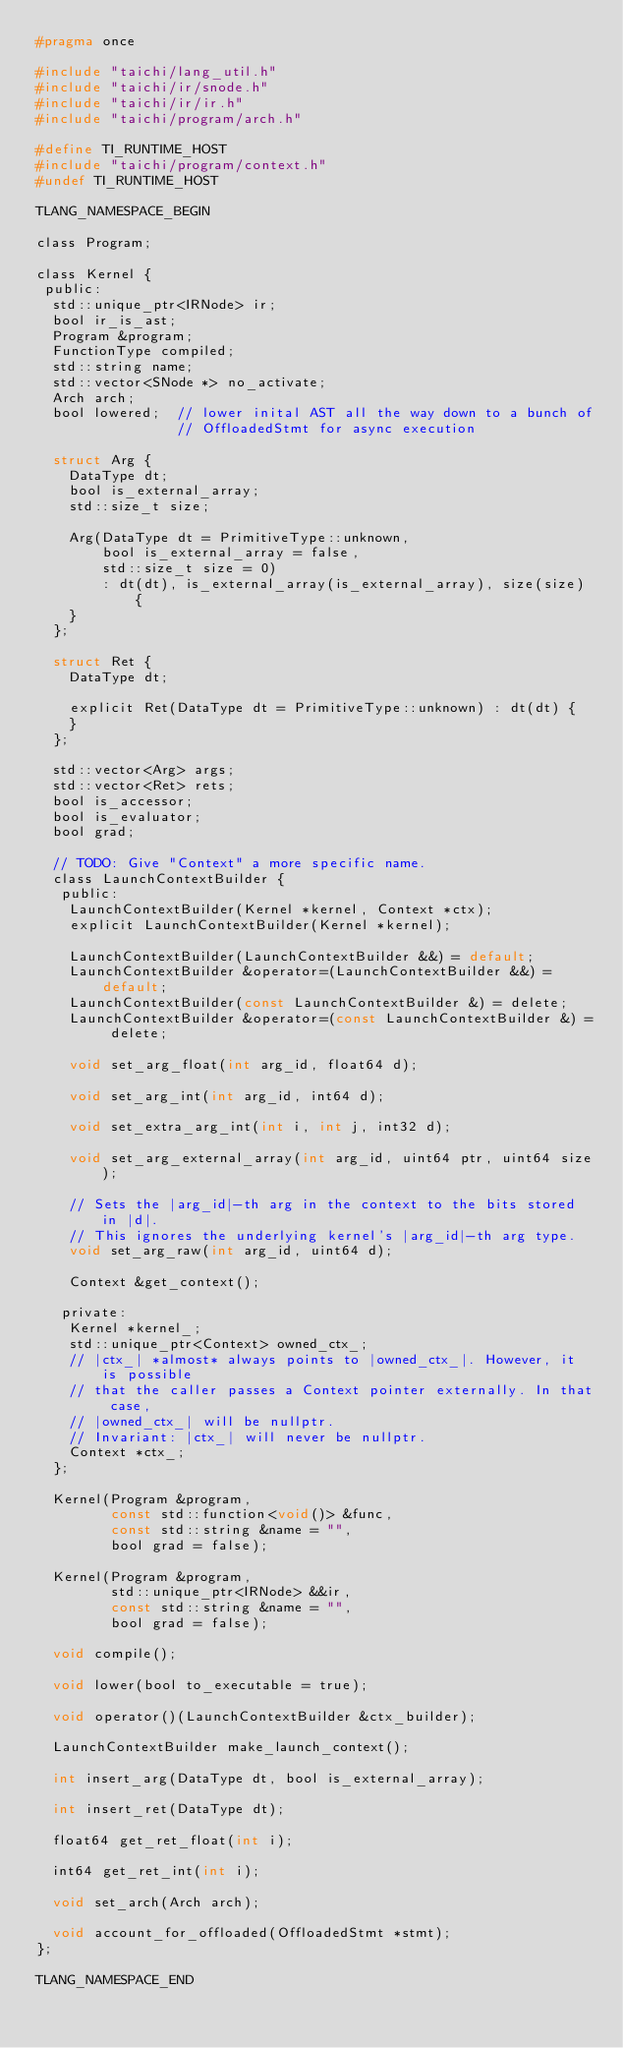<code> <loc_0><loc_0><loc_500><loc_500><_C_>#pragma once

#include "taichi/lang_util.h"
#include "taichi/ir/snode.h"
#include "taichi/ir/ir.h"
#include "taichi/program/arch.h"

#define TI_RUNTIME_HOST
#include "taichi/program/context.h"
#undef TI_RUNTIME_HOST

TLANG_NAMESPACE_BEGIN

class Program;

class Kernel {
 public:
  std::unique_ptr<IRNode> ir;
  bool ir_is_ast;
  Program &program;
  FunctionType compiled;
  std::string name;
  std::vector<SNode *> no_activate;
  Arch arch;
  bool lowered;  // lower inital AST all the way down to a bunch of
                 // OffloadedStmt for async execution

  struct Arg {
    DataType dt;
    bool is_external_array;
    std::size_t size;

    Arg(DataType dt = PrimitiveType::unknown,
        bool is_external_array = false,
        std::size_t size = 0)
        : dt(dt), is_external_array(is_external_array), size(size) {
    }
  };

  struct Ret {
    DataType dt;

    explicit Ret(DataType dt = PrimitiveType::unknown) : dt(dt) {
    }
  };

  std::vector<Arg> args;
  std::vector<Ret> rets;
  bool is_accessor;
  bool is_evaluator;
  bool grad;

  // TODO: Give "Context" a more specific name.
  class LaunchContextBuilder {
   public:
    LaunchContextBuilder(Kernel *kernel, Context *ctx);
    explicit LaunchContextBuilder(Kernel *kernel);

    LaunchContextBuilder(LaunchContextBuilder &&) = default;
    LaunchContextBuilder &operator=(LaunchContextBuilder &&) = default;
    LaunchContextBuilder(const LaunchContextBuilder &) = delete;
    LaunchContextBuilder &operator=(const LaunchContextBuilder &) = delete;

    void set_arg_float(int arg_id, float64 d);

    void set_arg_int(int arg_id, int64 d);

    void set_extra_arg_int(int i, int j, int32 d);

    void set_arg_external_array(int arg_id, uint64 ptr, uint64 size);

    // Sets the |arg_id|-th arg in the context to the bits stored in |d|.
    // This ignores the underlying kernel's |arg_id|-th arg type.
    void set_arg_raw(int arg_id, uint64 d);

    Context &get_context();

   private:
    Kernel *kernel_;
    std::unique_ptr<Context> owned_ctx_;
    // |ctx_| *almost* always points to |owned_ctx_|. However, it is possible
    // that the caller passes a Context pointer externally. In that case,
    // |owned_ctx_| will be nullptr.
    // Invariant: |ctx_| will never be nullptr.
    Context *ctx_;
  };

  Kernel(Program &program,
         const std::function<void()> &func,
         const std::string &name = "",
         bool grad = false);

  Kernel(Program &program,
         std::unique_ptr<IRNode> &&ir,
         const std::string &name = "",
         bool grad = false);

  void compile();

  void lower(bool to_executable = true);

  void operator()(LaunchContextBuilder &ctx_builder);

  LaunchContextBuilder make_launch_context();

  int insert_arg(DataType dt, bool is_external_array);

  int insert_ret(DataType dt);

  float64 get_ret_float(int i);

  int64 get_ret_int(int i);

  void set_arch(Arch arch);

  void account_for_offloaded(OffloadedStmt *stmt);
};

TLANG_NAMESPACE_END
</code> 